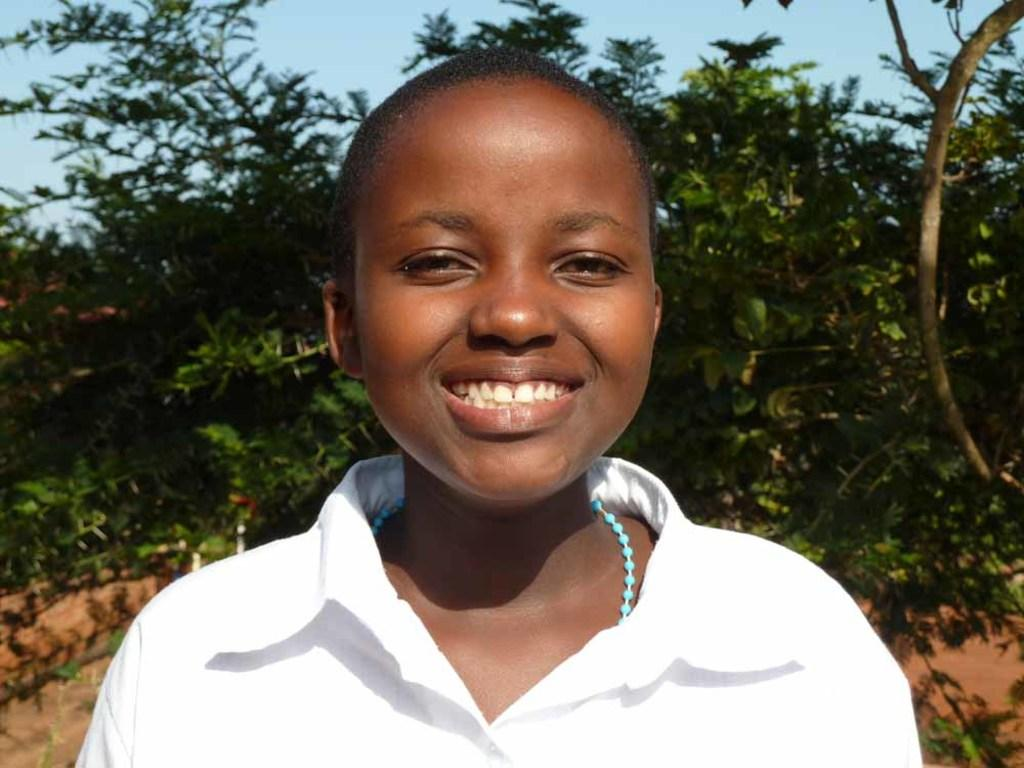Who or what is the main subject of the image? There is a person in the image. What can be seen in the background of the image? There are trees and the sky visible in the background of the image. What type of ticket is the person holding in the image? There is no ticket present in the image; it only features a person and the background. 